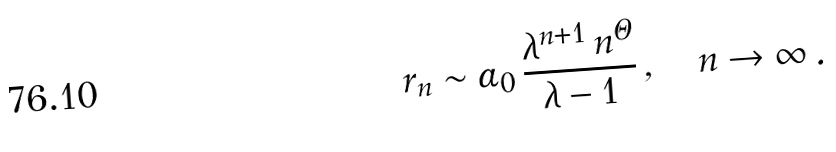Convert formula to latex. <formula><loc_0><loc_0><loc_500><loc_500>r _ { n } \sim \alpha _ { 0 } \, \frac { \lambda ^ { n + 1 } \, n ^ { \Theta } } { \lambda - 1 } \, , \quad n \to \infty \, .</formula> 